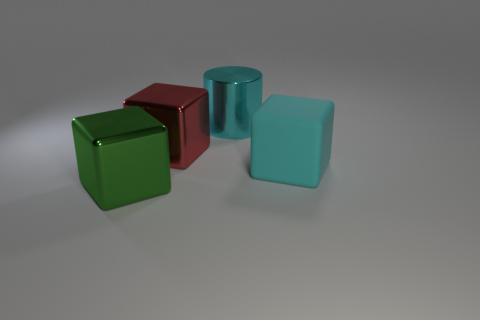Are the objects arranged in a pattern? The objects are not arranged in any discernible pattern. They are placed randomly on a flat surface, allowing the viewer to focus on the individual characteristics of each shape without being influenced by a specific arrangement. 